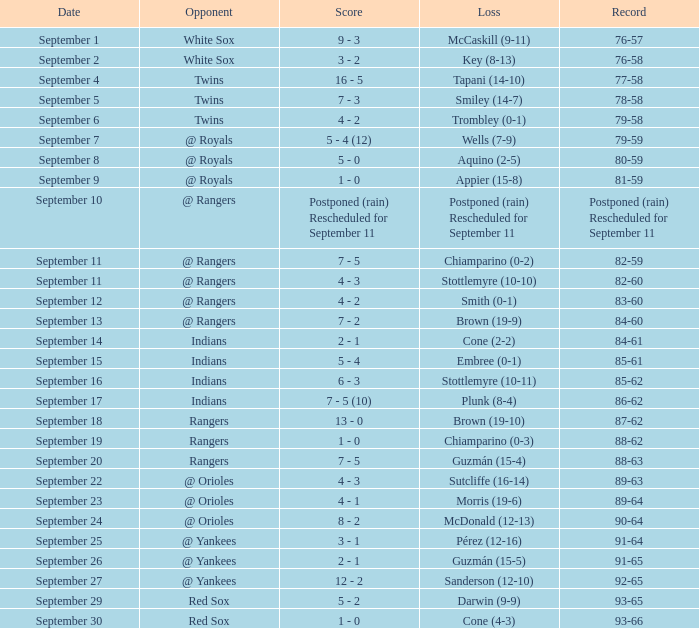What opponent has a record of 86-62? Indians. 